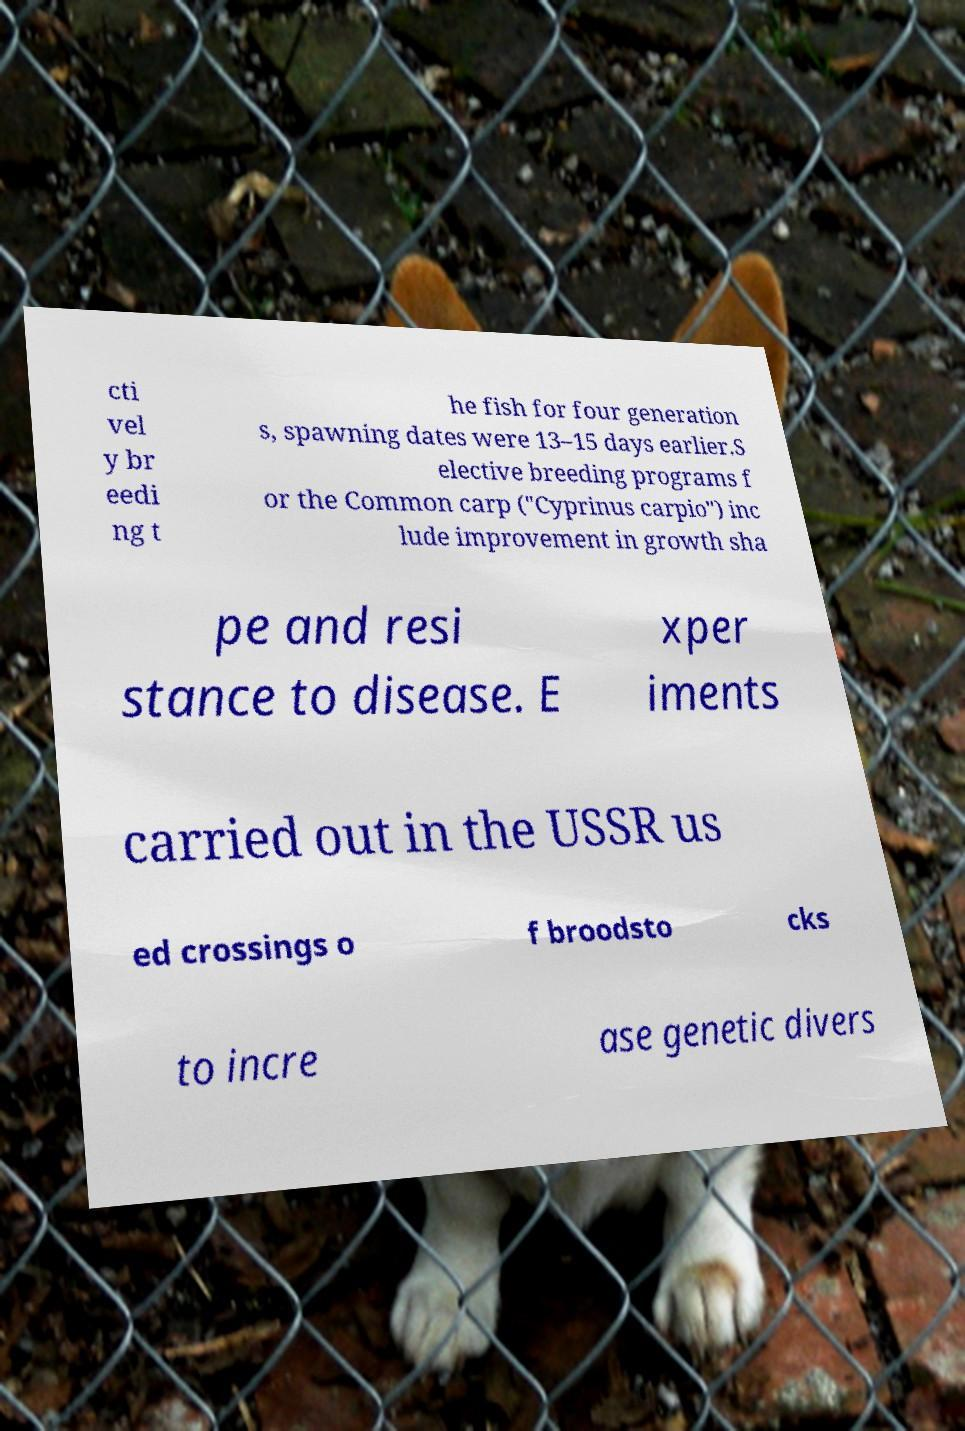Could you extract and type out the text from this image? cti vel y br eedi ng t he fish for four generation s, spawning dates were 13–15 days earlier.S elective breeding programs f or the Common carp ("Cyprinus carpio") inc lude improvement in growth sha pe and resi stance to disease. E xper iments carried out in the USSR us ed crossings o f broodsto cks to incre ase genetic divers 